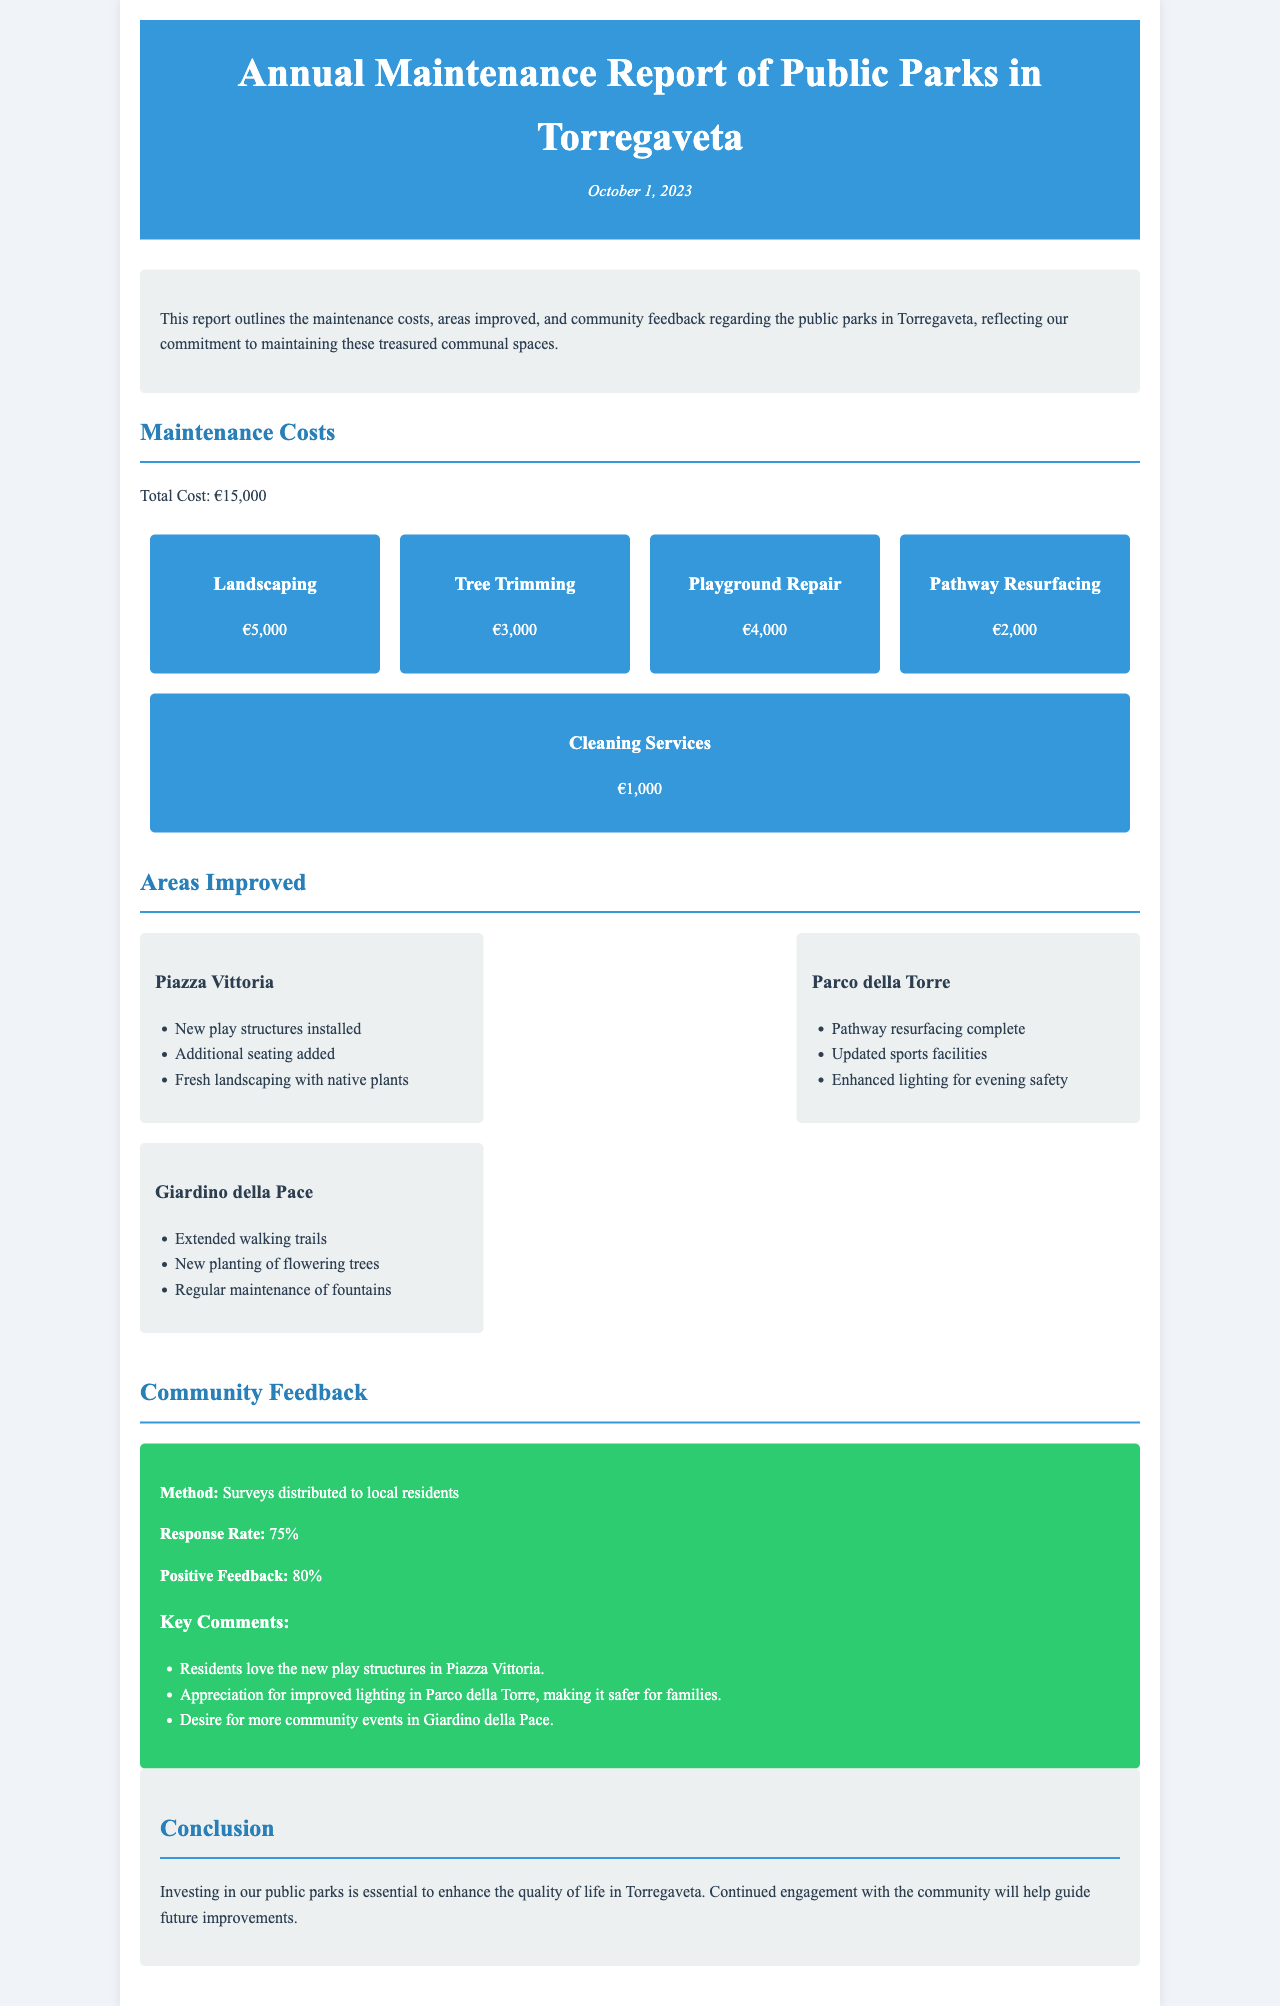What is the total maintenance cost? The total maintenance cost is stated at the beginning of the section on Maintenance Costs.
Answer: €15,000 How much was spent on landscaping? The expenditure for landscaping is listed among the detailed costs in the Maintenance Costs section.
Answer: €5,000 Which park had new play structures installed? The park where new play structures were installed is mentioned in the Areas Improved section.
Answer: Piazza Vittoria What percentage of community feedback was positive? The positive feedback percentage is provided in the Community Feedback section.
Answer: 80% What improvement was made in Parco della Torre? The improvements made in Parco della Torre are itemized in the Areas Improved section.
Answer: Updated sports facilities What method was used to gather community feedback? The method used for gathering feedback is specifically mentioned in the Community Feedback section.
Answer: Surveys distributed to local residents Which park had enhanced lighting for evening safety? The specific improvement mentioned for evening safety is noted under the respective park in the Areas Improved section.
Answer: Parco della Torre What is the response rate for the community feedback? The response rate for community feedback is clearly stated under the Community Feedback section.
Answer: 75% 